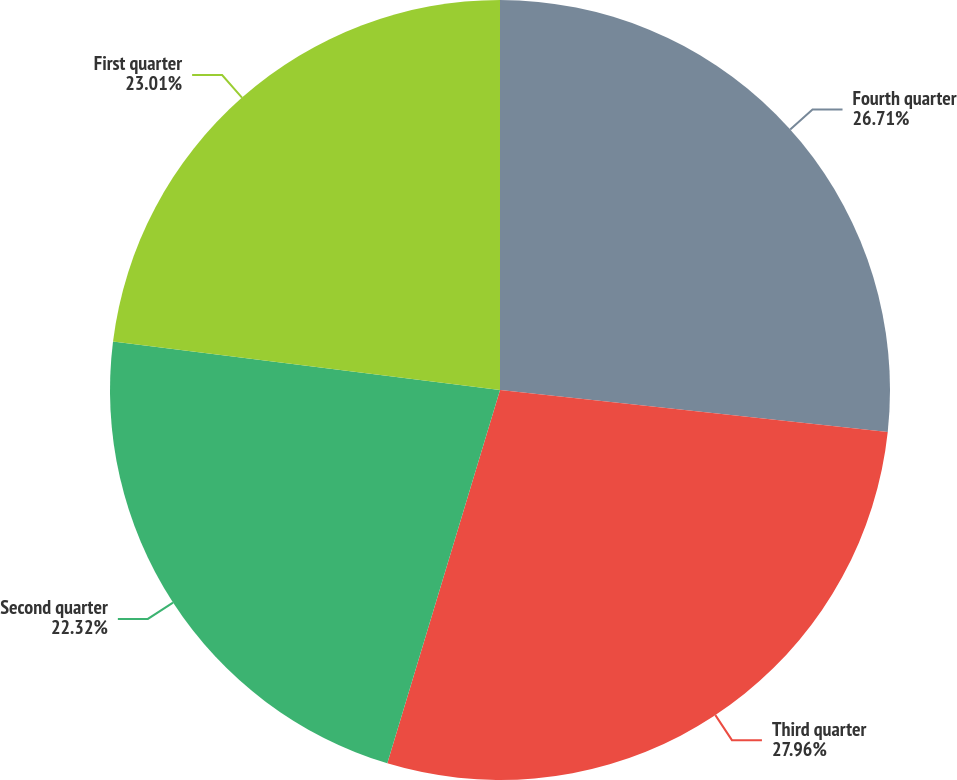Convert chart. <chart><loc_0><loc_0><loc_500><loc_500><pie_chart><fcel>Fourth quarter<fcel>Third quarter<fcel>Second quarter<fcel>First quarter<nl><fcel>26.71%<fcel>27.95%<fcel>22.32%<fcel>23.01%<nl></chart> 